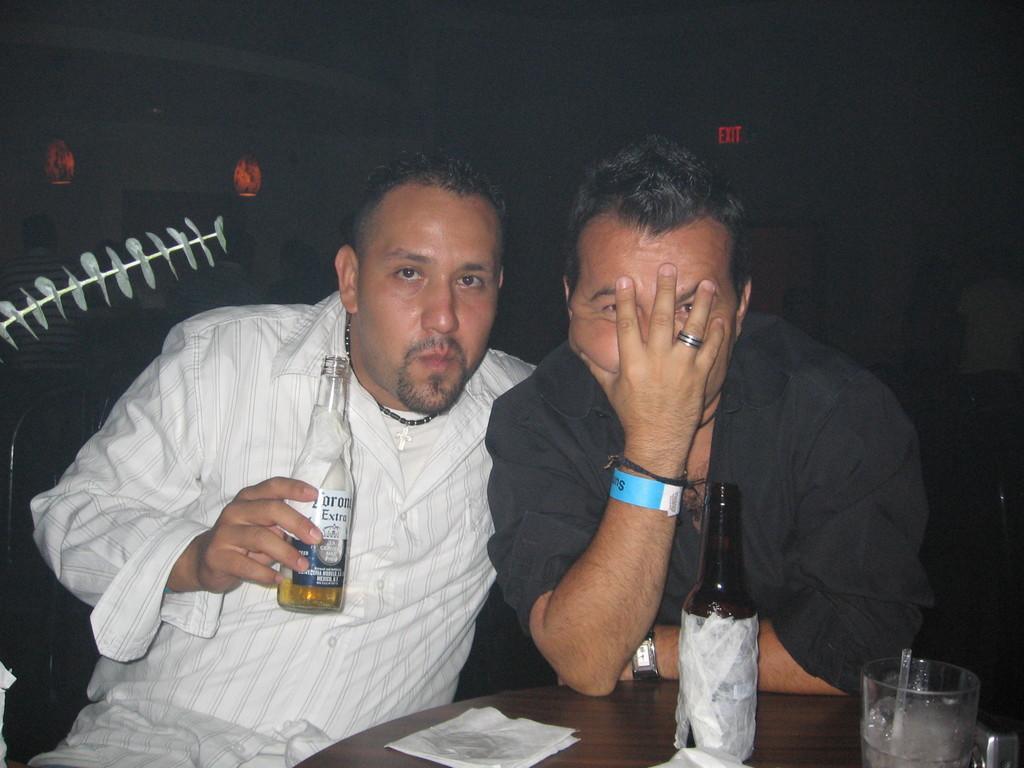How would you summarize this image in a sentence or two? On the left, there is a person in white color shirt, holding a bottle which is filled with drink and sitting. Beside him, there is another person in black color shirt, sitting, keeping elbow on the table and covered his face with his hand. On the table, there is a bottle, a glass and papers. And the background is dark in color. 